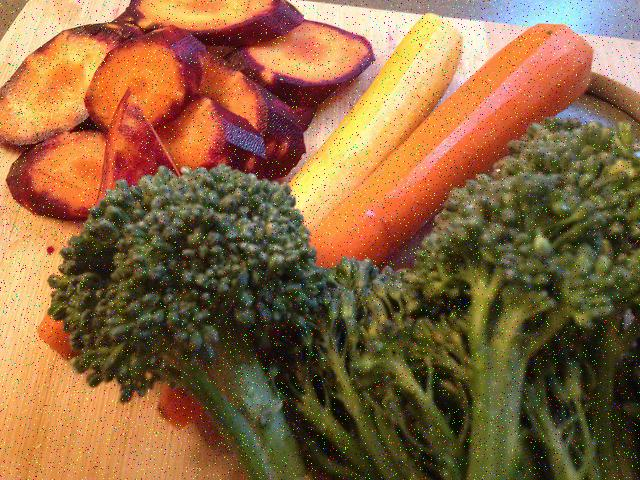Could this image be portraying a specific type of diet or lifestyle? Yes, the selection of vegetables like beets, carrots, and broccoli, which are known for their health benefits, suggests a focus on clean eating or a plant-based diet. Such a meal choice might appeal to those looking to maintain a balanced diet, vegetarians, or individuals intrigued by the natural, whole foods lifestyle. 